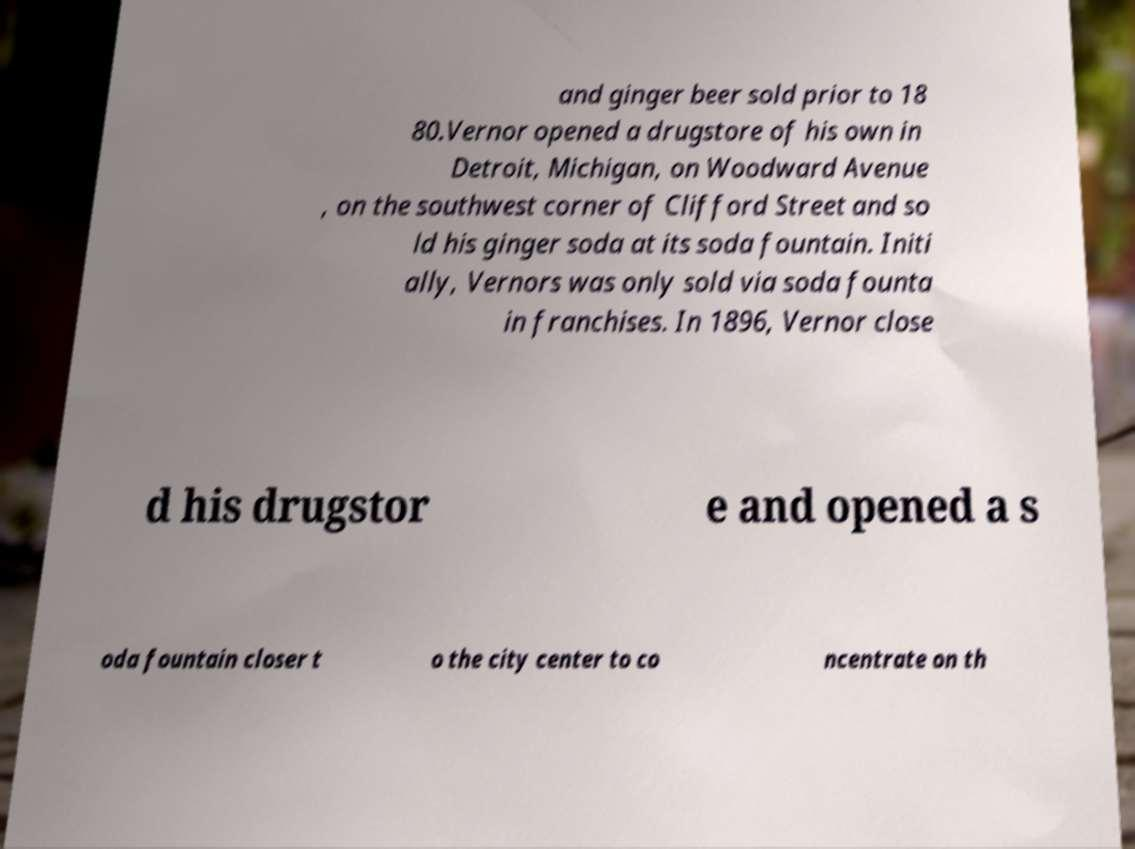Could you extract and type out the text from this image? and ginger beer sold prior to 18 80.Vernor opened a drugstore of his own in Detroit, Michigan, on Woodward Avenue , on the southwest corner of Clifford Street and so ld his ginger soda at its soda fountain. Initi ally, Vernors was only sold via soda founta in franchises. In 1896, Vernor close d his drugstor e and opened a s oda fountain closer t o the city center to co ncentrate on th 